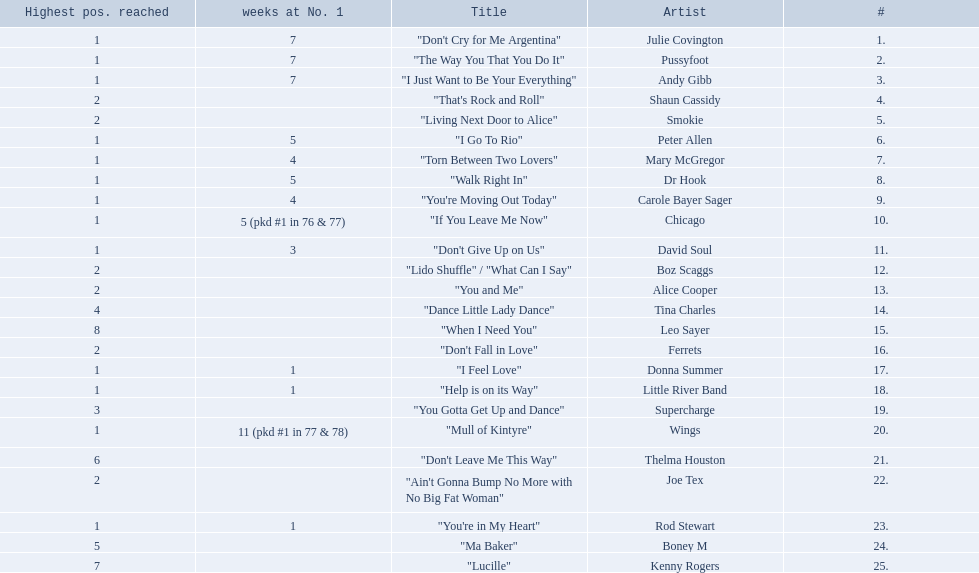How long is the longest amount of time spent at number 1? 11 (pkd #1 in 77 & 78). What song spent 11 weeks at number 1? "Mull of Kintyre". What band had a number 1 hit with this song? Wings. 